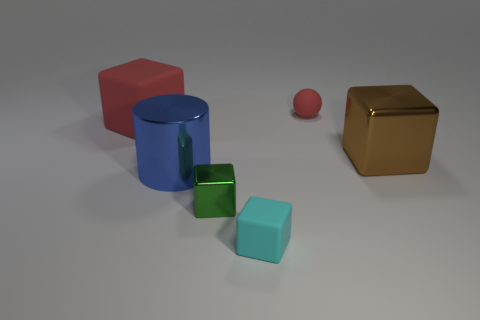Add 1 small shiny cylinders. How many objects exist? 7 Subtract all tiny green metallic blocks. How many blocks are left? 3 Subtract all cylinders. How many objects are left? 5 Subtract 1 balls. How many balls are left? 0 Add 5 tiny red things. How many tiny red things are left? 6 Add 5 big brown metallic blocks. How many big brown metallic blocks exist? 6 Subtract all cyan blocks. How many blocks are left? 3 Subtract 1 red cubes. How many objects are left? 5 Subtract all brown cylinders. Subtract all blue spheres. How many cylinders are left? 1 Subtract all cyan spheres. How many red blocks are left? 1 